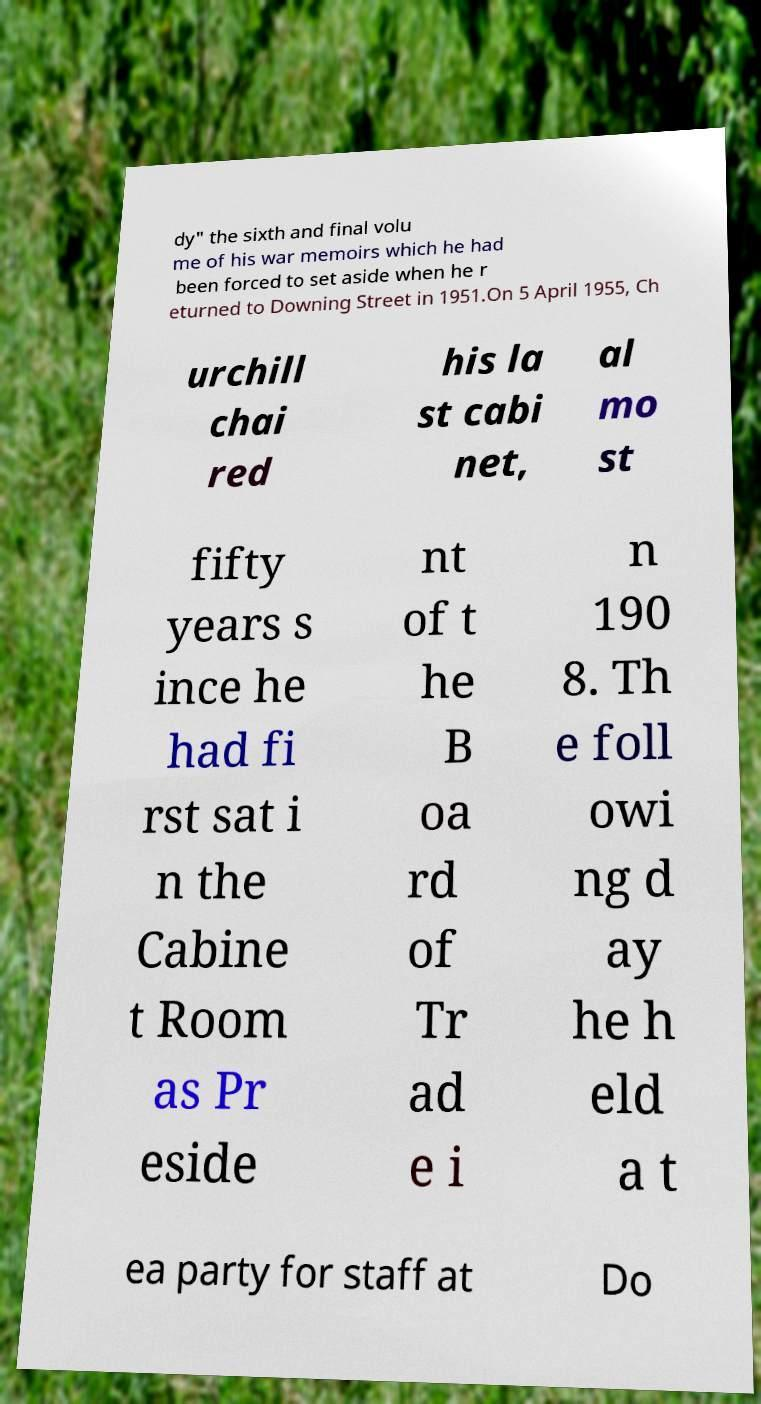Please identify and transcribe the text found in this image. dy" the sixth and final volu me of his war memoirs which he had been forced to set aside when he r eturned to Downing Street in 1951.On 5 April 1955, Ch urchill chai red his la st cabi net, al mo st fifty years s ince he had fi rst sat i n the Cabine t Room as Pr eside nt of t he B oa rd of Tr ad e i n 190 8. Th e foll owi ng d ay he h eld a t ea party for staff at Do 